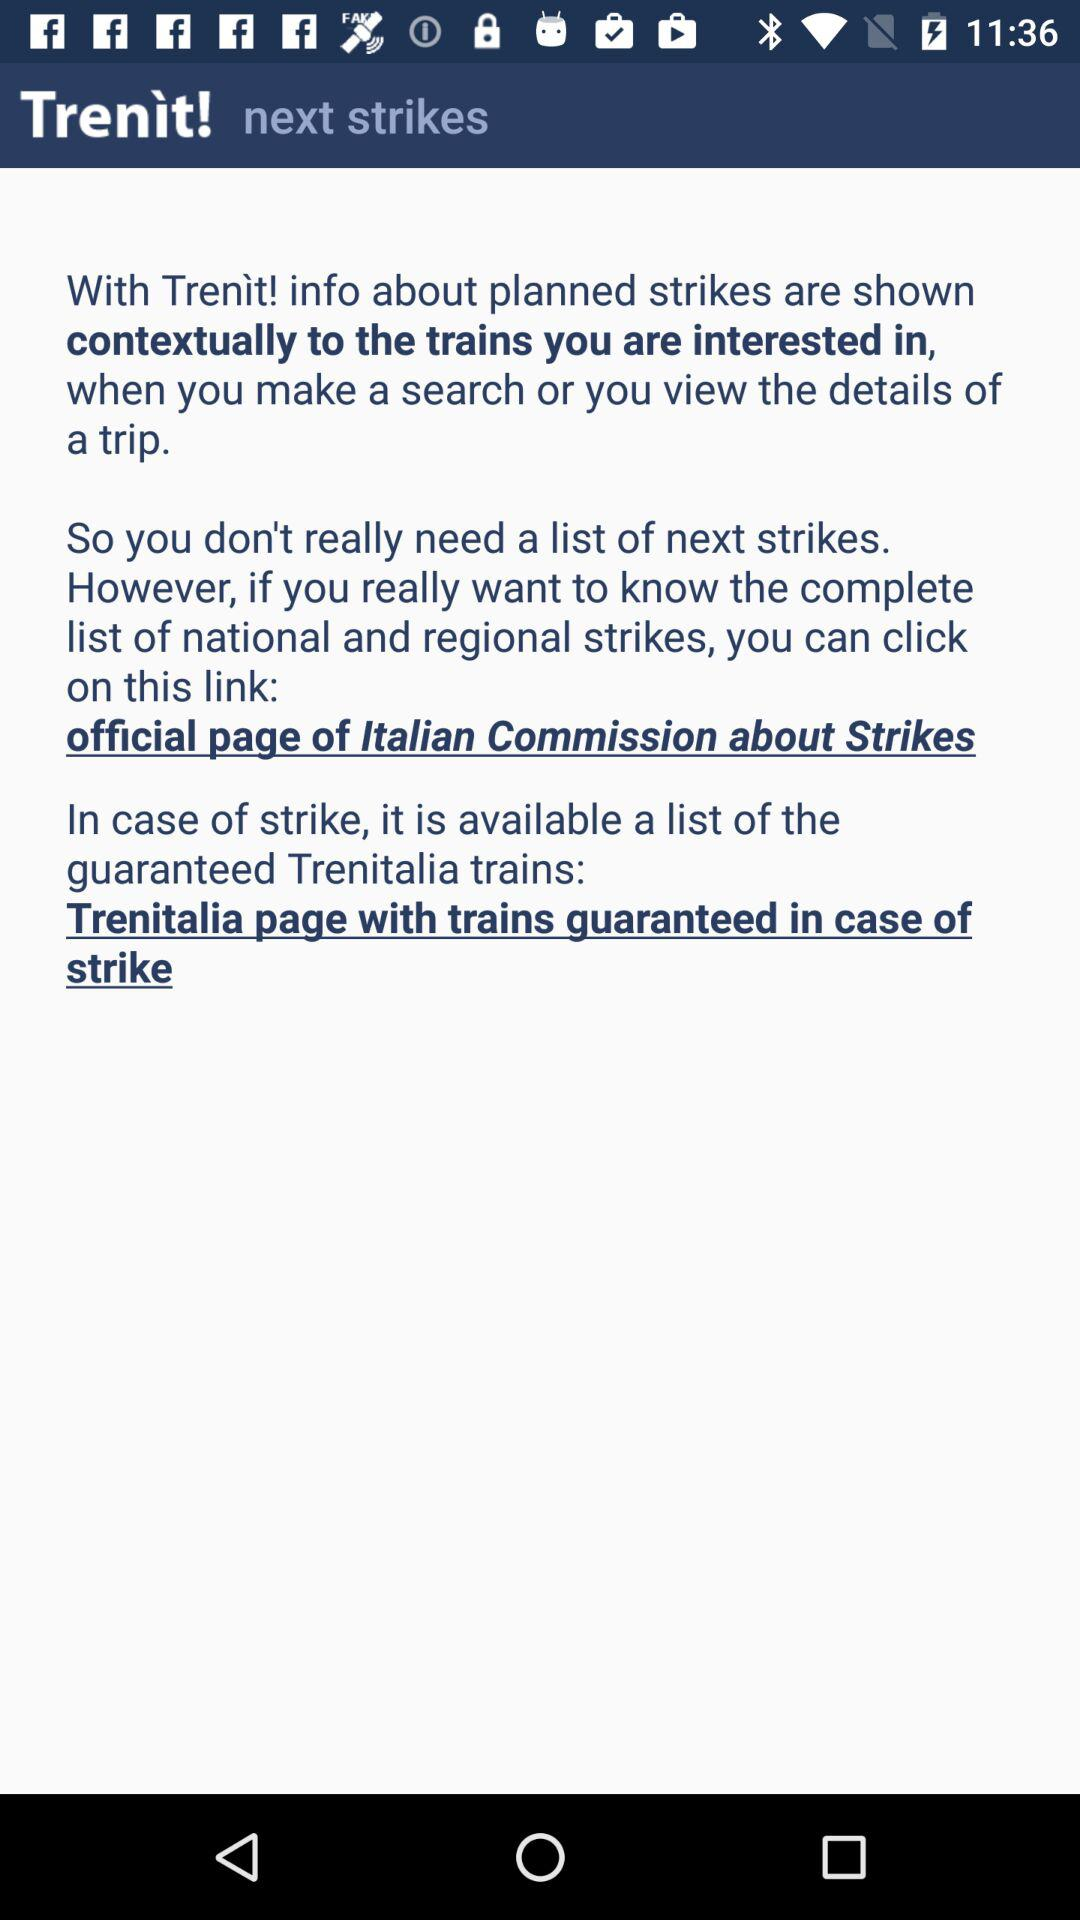What is the name of the application? The application name is "Trenit!". 